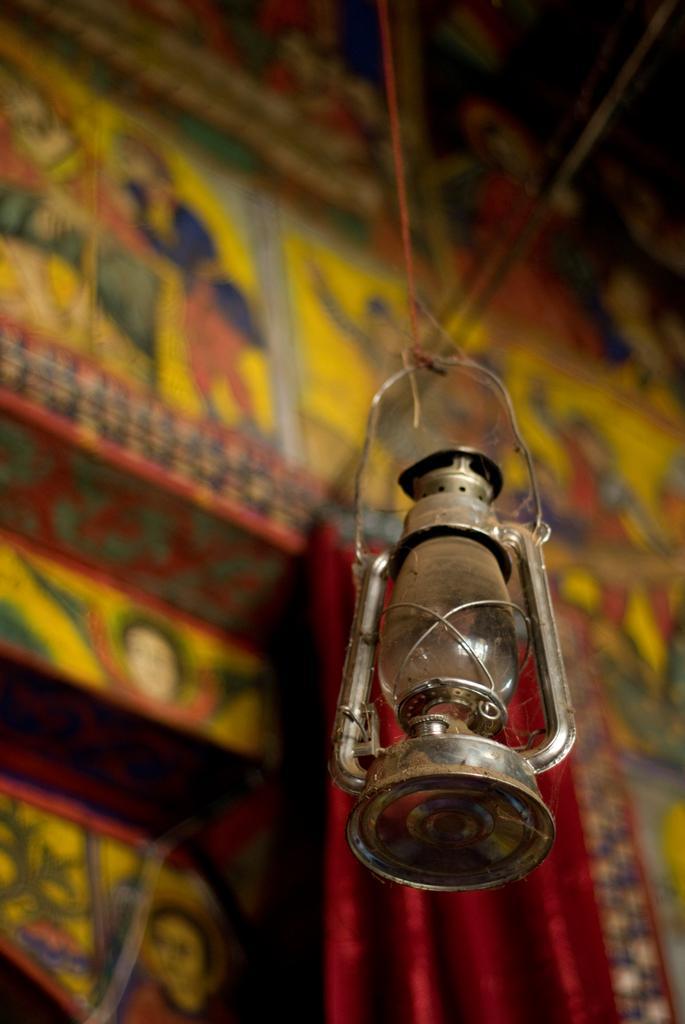Please provide a concise description of this image. In the front of the image there is a lantern lamp. In the background of the image is blurred and there is a designed wall. 